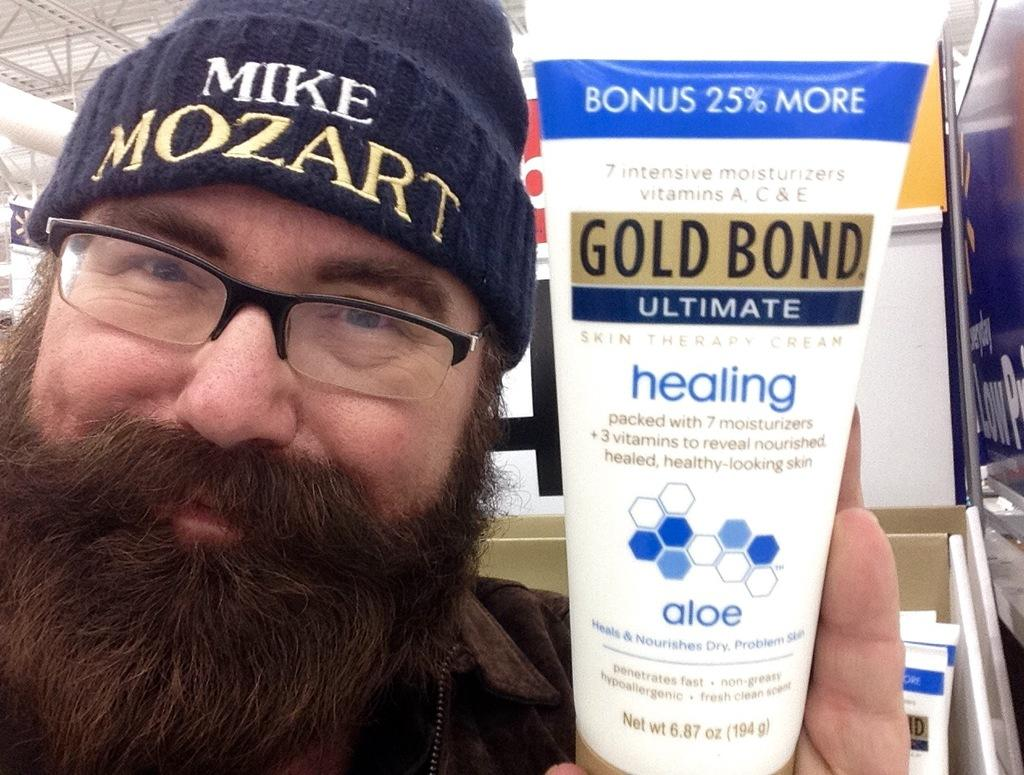<image>
Describe the image concisely. a man holding a squeeze tube that is labeled 'gold bond ultimate' 